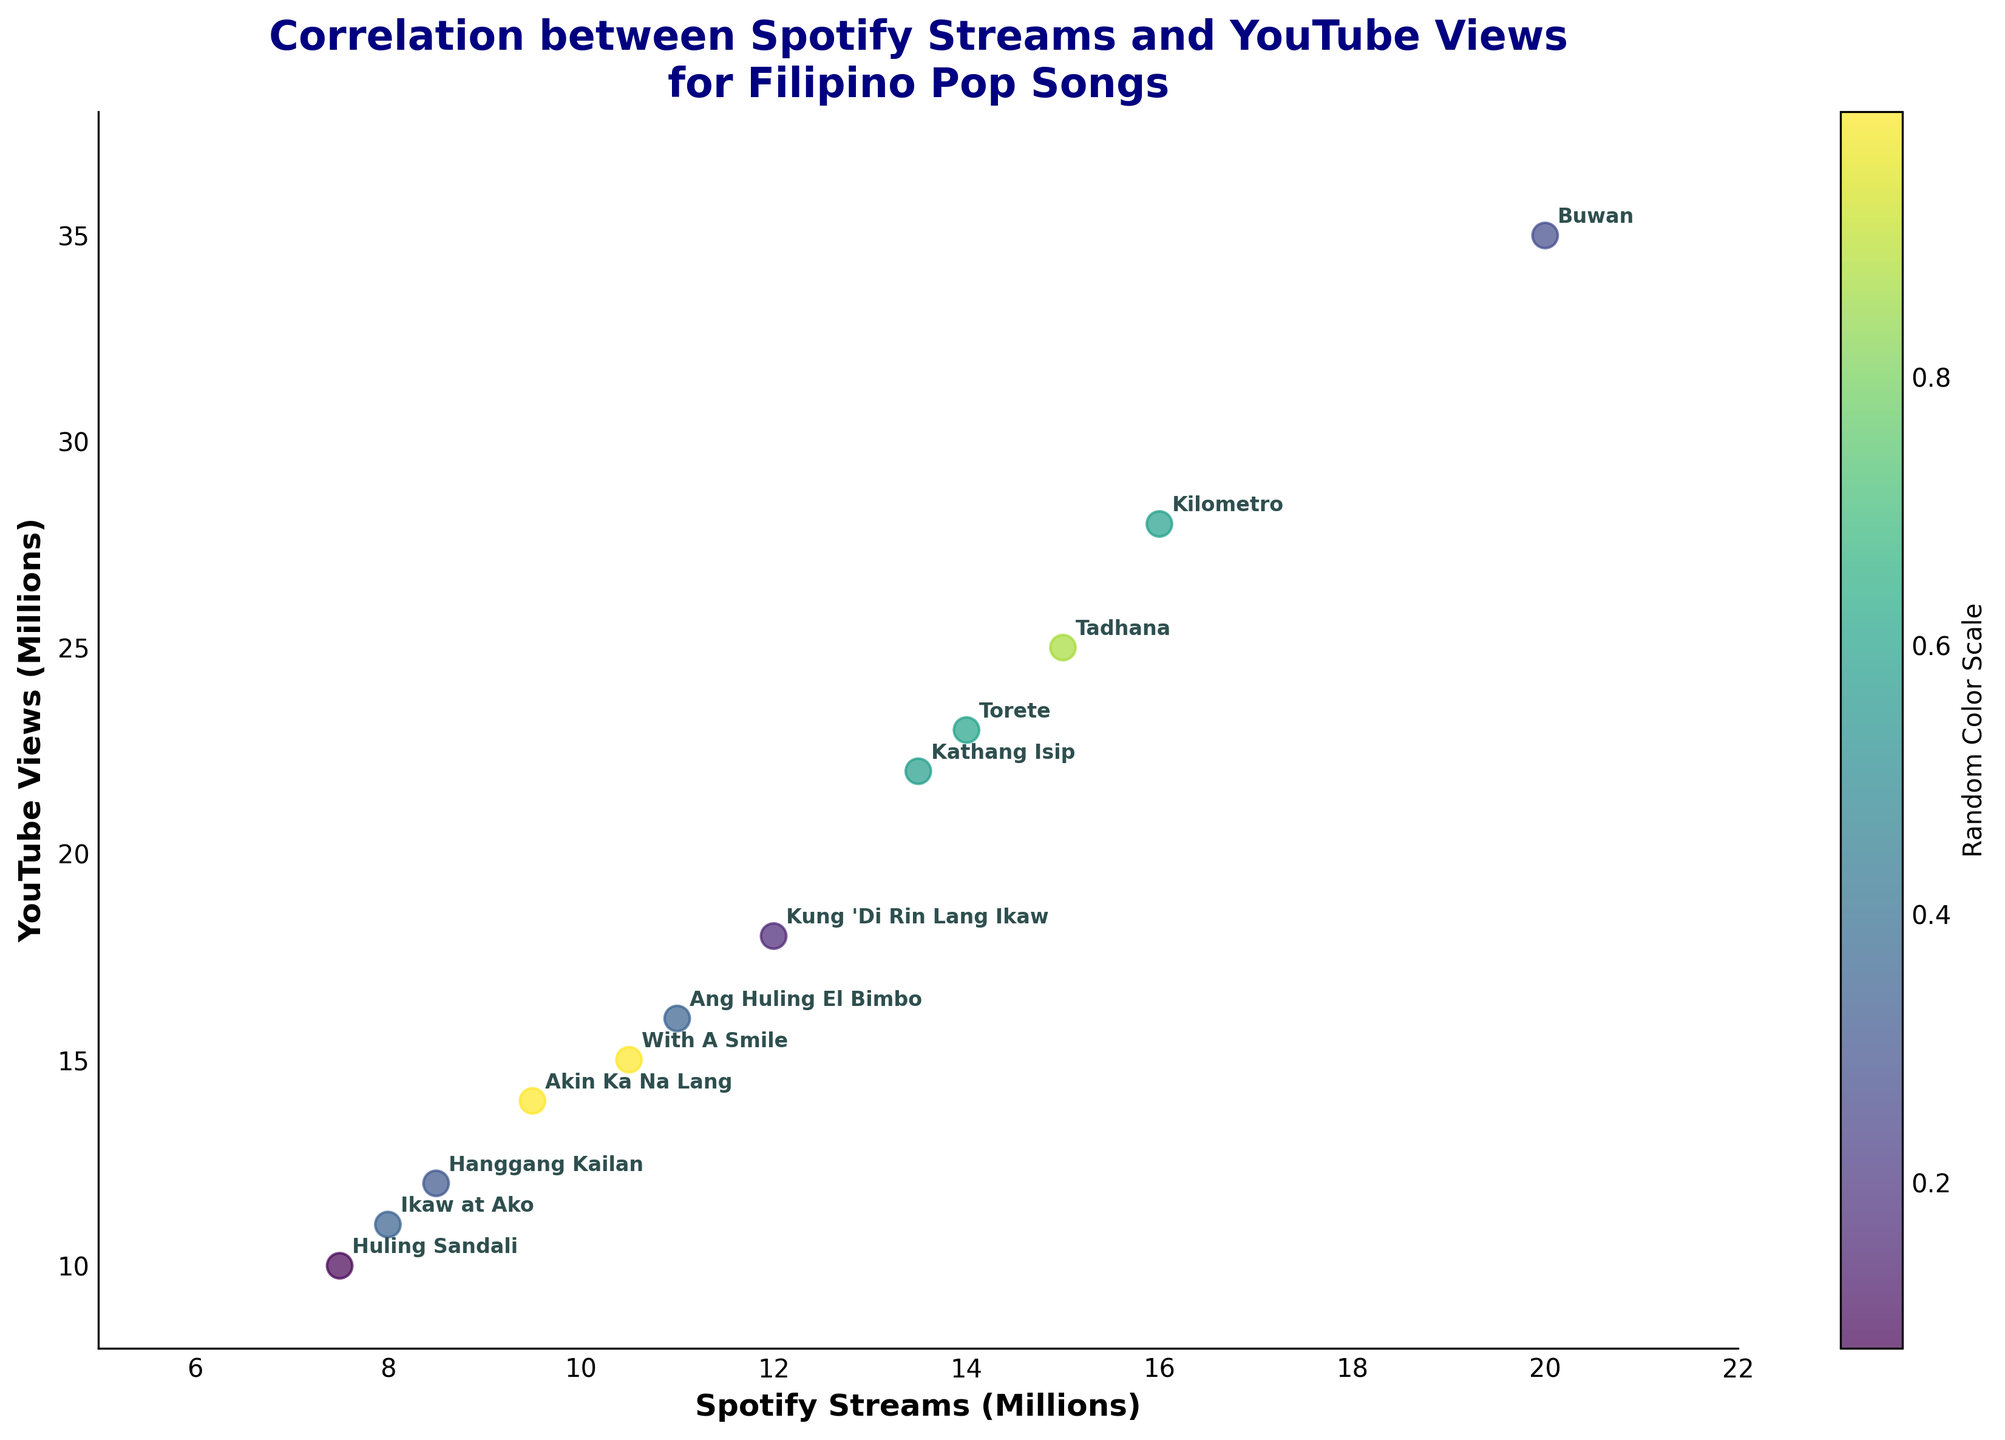What is the title of the plot? The title of the plot is written at the top of the figure and provides an overview of the content depicted.
Answer: Correlation between Spotify Streams and YouTube Views for Filipino Pop Songs How many songs are represented in the plot? To determine the number of songs, count the number of distinct points or annotations in the plot.
Answer: 12 Which song has the highest number of YouTube views? Look for the data point with the highest value on the Y-axis and check the corresponding annotation.
Answer: Buwan What is the range of Spotify streams values shown on the X-axis? The X-axis range can be determined by looking at the axis limits labeled with the minimum and maximum values.
Answer: 5 to 22 million How do the Spotify streams for "Tadhana" compare to those for "Akin Ka Na Lang"? Find the corresponding data points/annotations and compare the X-axis values.
Answer: Tadhana has more streams than Akin Ka Na Lang What is the average number of YouTube views for all the songs? Add up all the YouTube views values and divide by the number of songs (12). (25000000 + 18000000 + 14000000 + 11000000 + 35000000 + 22000000 + 16000000 + 15000000 + 10000000 + 23000000 + 12000000 + 28000000) / 12 = 22416667
Answer: 22.4 million Which song has the smallest difference between Spotify streams and YouTube views? Calculate the absolute differences for each song and identify the smallest one. (Tadhana: 10000000, Kung 'Di Rin Lang Ikaw: 6000000, Akin Ka Na Lang: 4500000, Ikaw at Ako: 3000000, Buwan: 15000000, Kathang Isip: 8500000, Ang Huling El Bimbo: 5000000, With A Smile: 4500000, Huling Sandali: 2500000, Torete: 9000000, Hanggang Kailan: 3500000, Kilometro: 12000000)
Answer: Huling Sandali How are the color and size used in the plot? Color represents a random color scale and size indicates a constant size for all points, both for visual differentiation.
Answer: Color differentiates, size is uniform What insight do we gather about the relationship between Spotify streams and YouTube views from this biplot? Observing the overall positive correlation where an increase in Spotify streams generally aligns with an increase in YouTube views.
Answer: Positive correlation Which songs have an equal or nearly equal number of Spotify streams and YouTube views? Find points where X-axis and Y-axis values are closest to each other. Look at annotations "Huling Sandali" (7.5M, 10M) and "Ikaw at Ako" (8M, 11M) for near similarities.
Answer: None exactly equal, closest: "Huling Sandali" and "Ikaw at Ako" 